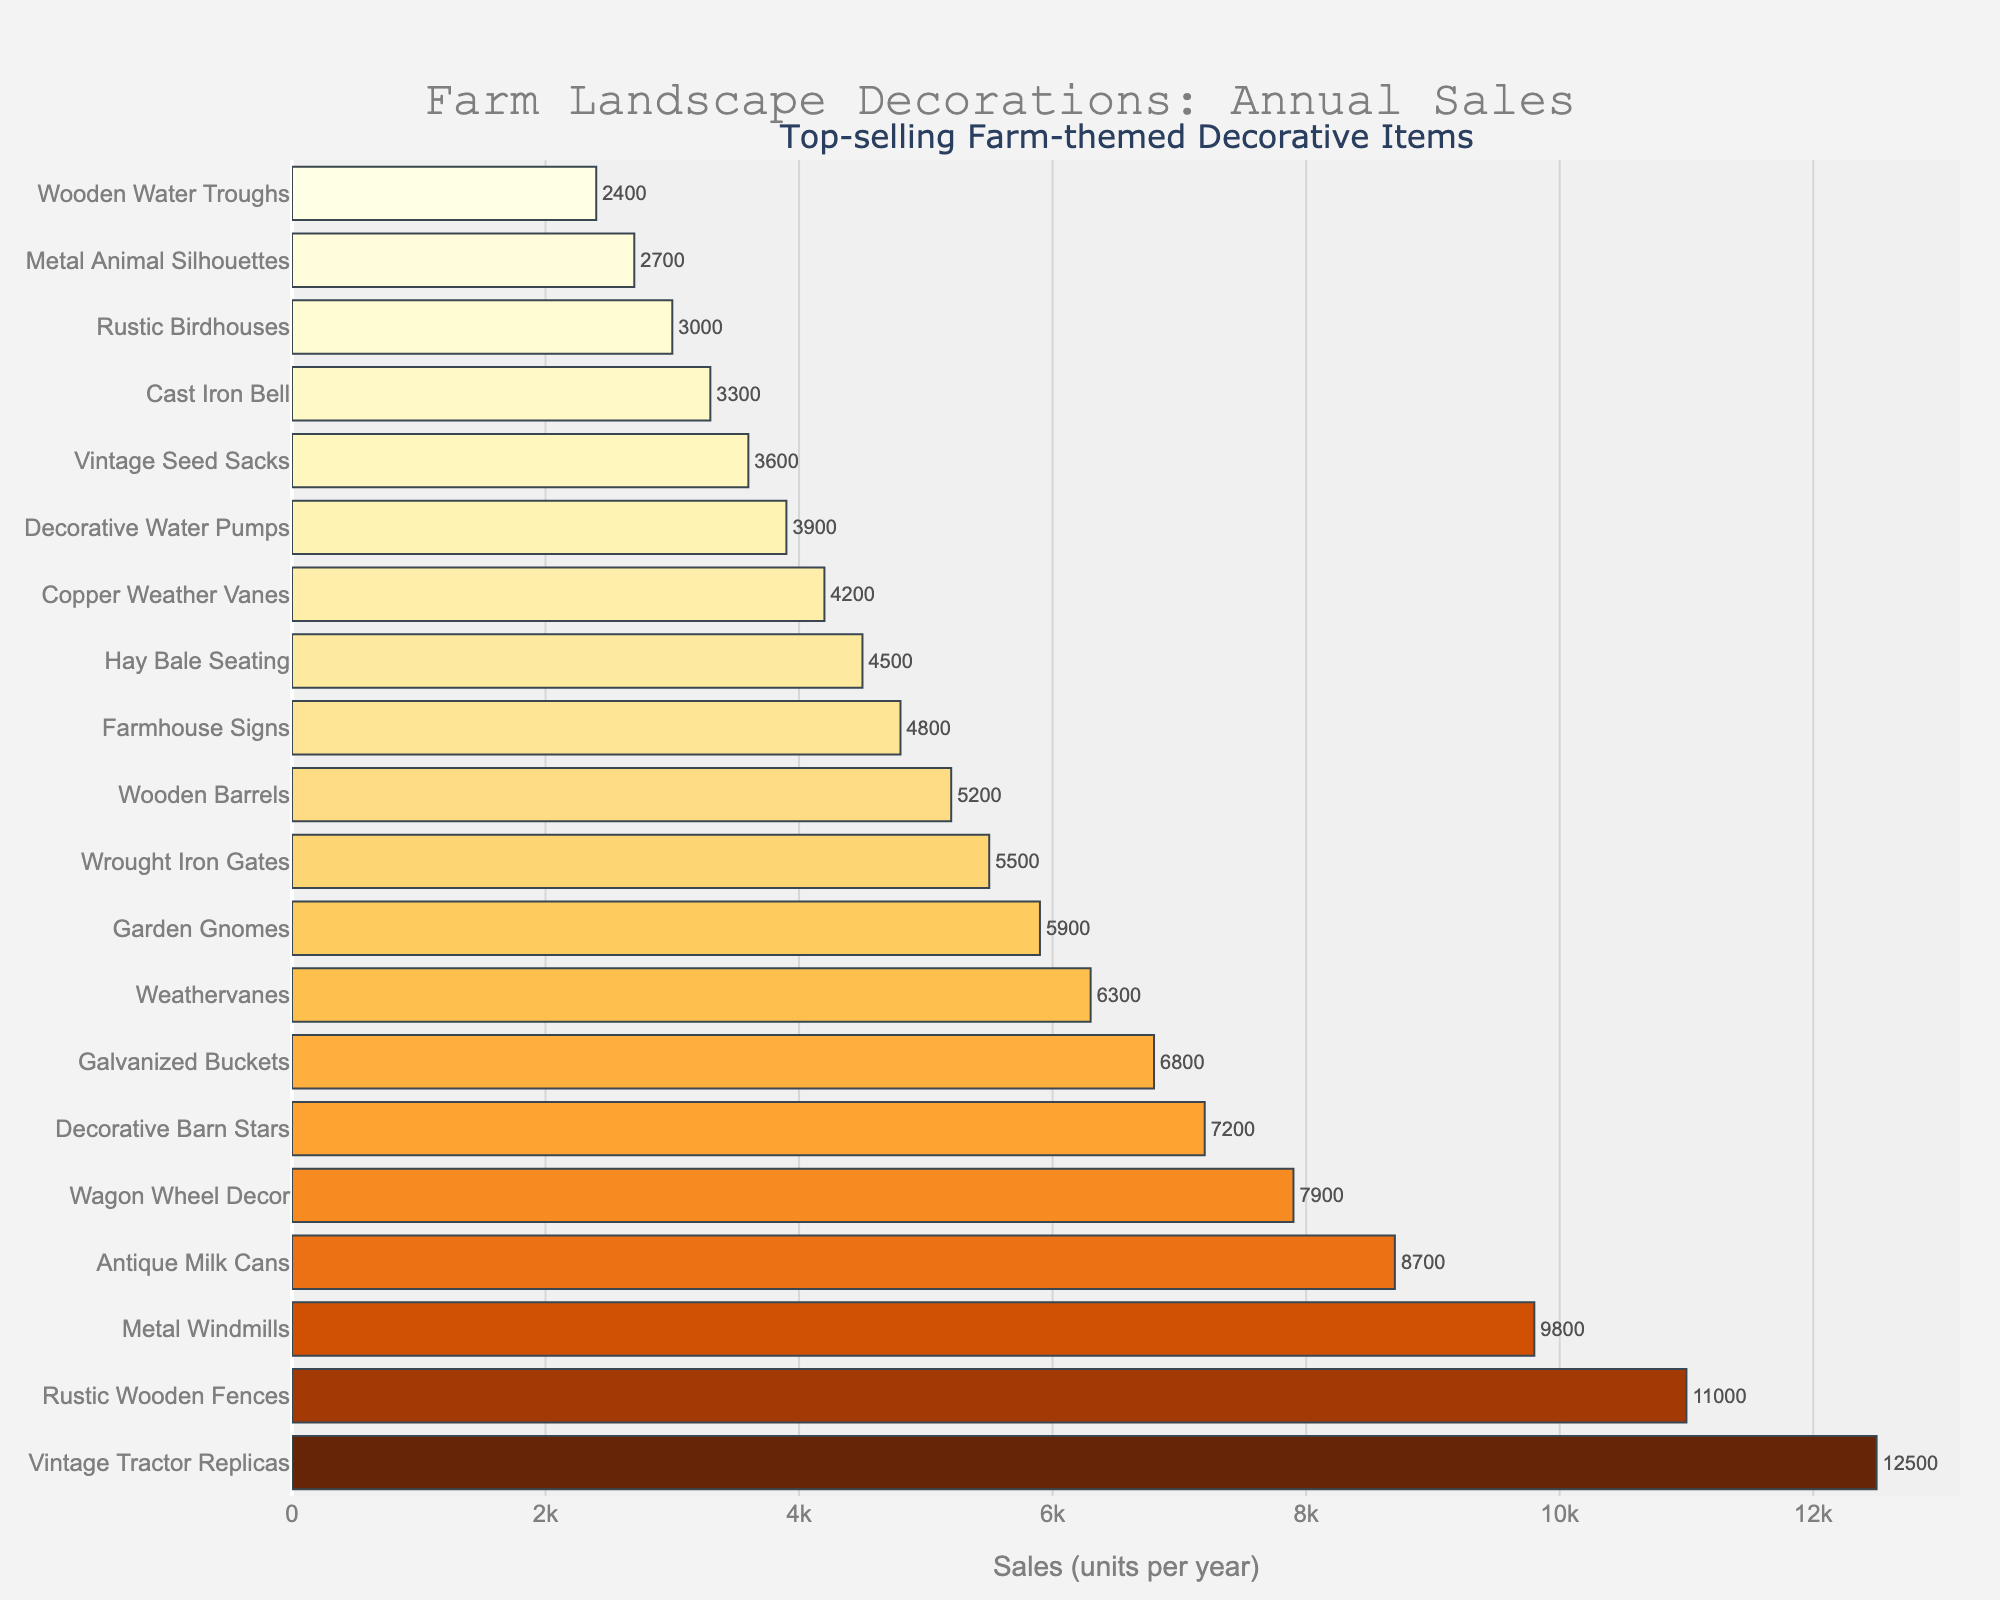What is the best-selling decorative item for farm landscapes? The chart shows the top-selling farm-themed decorative items. The item with the longest bar and highest sales units is the best-selling.
Answer: Vintage Tractor Replicas How much more does Vintage Tractor Replicas sell compared to Wagon Wheel Decor? The sales units of Vintage Tractor Replicas are 12500, and for Wagon Wheel Decor, it is 7900. The difference is 12500 - 7900 = 4600 units.
Answer: 4600 units What is the total sales of the top three selling items? The top three selling items are Vintage Tractor Replicas (12500), Rustic Wooden Fences (11000), and Metal Windmills (9800). Summing these values: 12500 + 11000 + 9800 = 33300 units.
Answer: 33300 units How many more units does the second best-selling item sell than the fourth? The second best-selling item is Rustic Wooden Fences with 11000 units, and the fourth is Antique Milk Cans with 8700 units. The difference is 11000 - 8700 = 2300 units.
Answer: 2300 units Which item has just a few units less in sales than Garden Gnomes? Garden Gnomes have sales of 5900 units. The item right below this is Wrought Iron Gates with sales of 5500 units, which is slightly less.
Answer: Wrought Iron Gates Are there more items with sales above or below 5000 units? Count the items with sales above 5000 and below 5000. Items above 5000: 10. Items below 5000: 10.
Answer: Equal What is the average sales of the bottom five selling items? The bottom five items based on sales are: Wooden Water Troughs (2400), Metal Animal Silhouettes (2700), Rustic Birdhouses (3000), Cast Iron Bell (3300), Vintage Seed Sacks (3600). Average = (2400 + 2700 + 3000 + 3300 + 3600) / 5 = 3000 units.
Answer: 3000 units Between Garden Gnomes and Weathervanes, which item sells more and by how much? Garden Gnomes sell 5900 units, and Weathervanes sell 6300 units. The difference is 6300 - 5900 = 400 units, with Weathervanes selling more.
Answer: Weathervanes by 400 units Which items have sales between 4000 and 7000 units? The items with sales between 4000 and 7000 units are: Decorative Barn Stars (7200 - slightly above 7000), Galvanized Buckets (6800), Weathervanes (6300), Garden Gnomes (5900), and Wrought Iron Gates (5500).
Answer: Galvanized Buckets, Weathervanes, Garden Gnomes, Wrought Iron Gates 